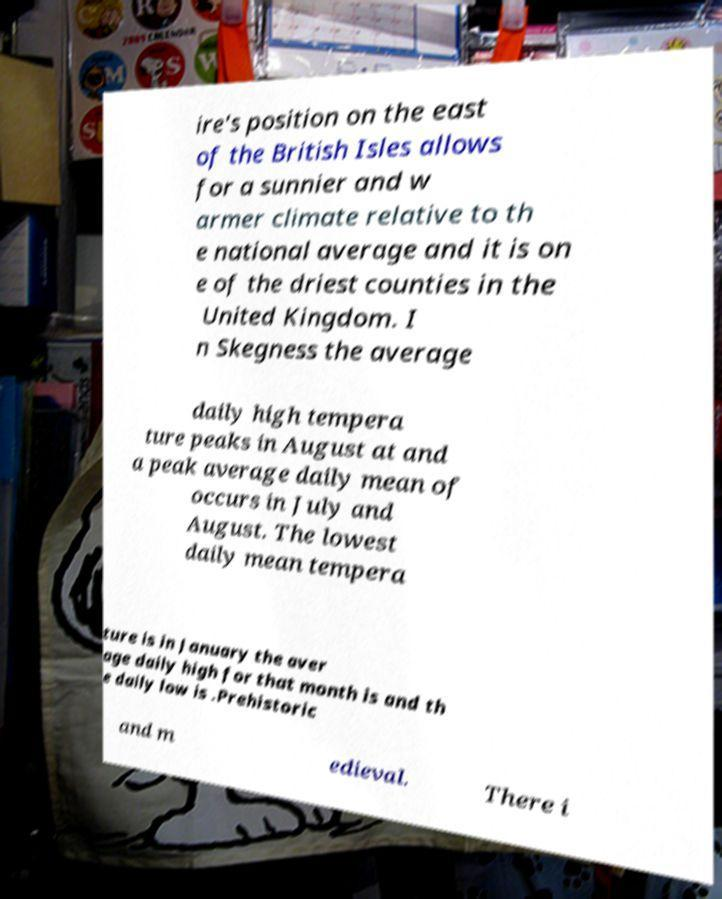Please identify and transcribe the text found in this image. ire's position on the east of the British Isles allows for a sunnier and w armer climate relative to th e national average and it is on e of the driest counties in the United Kingdom. I n Skegness the average daily high tempera ture peaks in August at and a peak average daily mean of occurs in July and August. The lowest daily mean tempera ture is in January the aver age daily high for that month is and th e daily low is .Prehistoric and m edieval. There i 